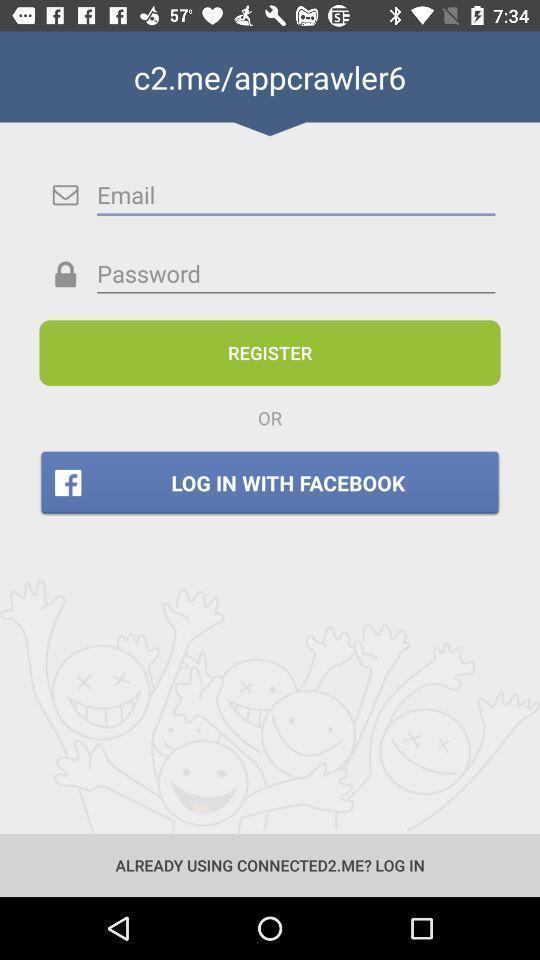Tell me what you see in this picture. Signup page of a social app. 